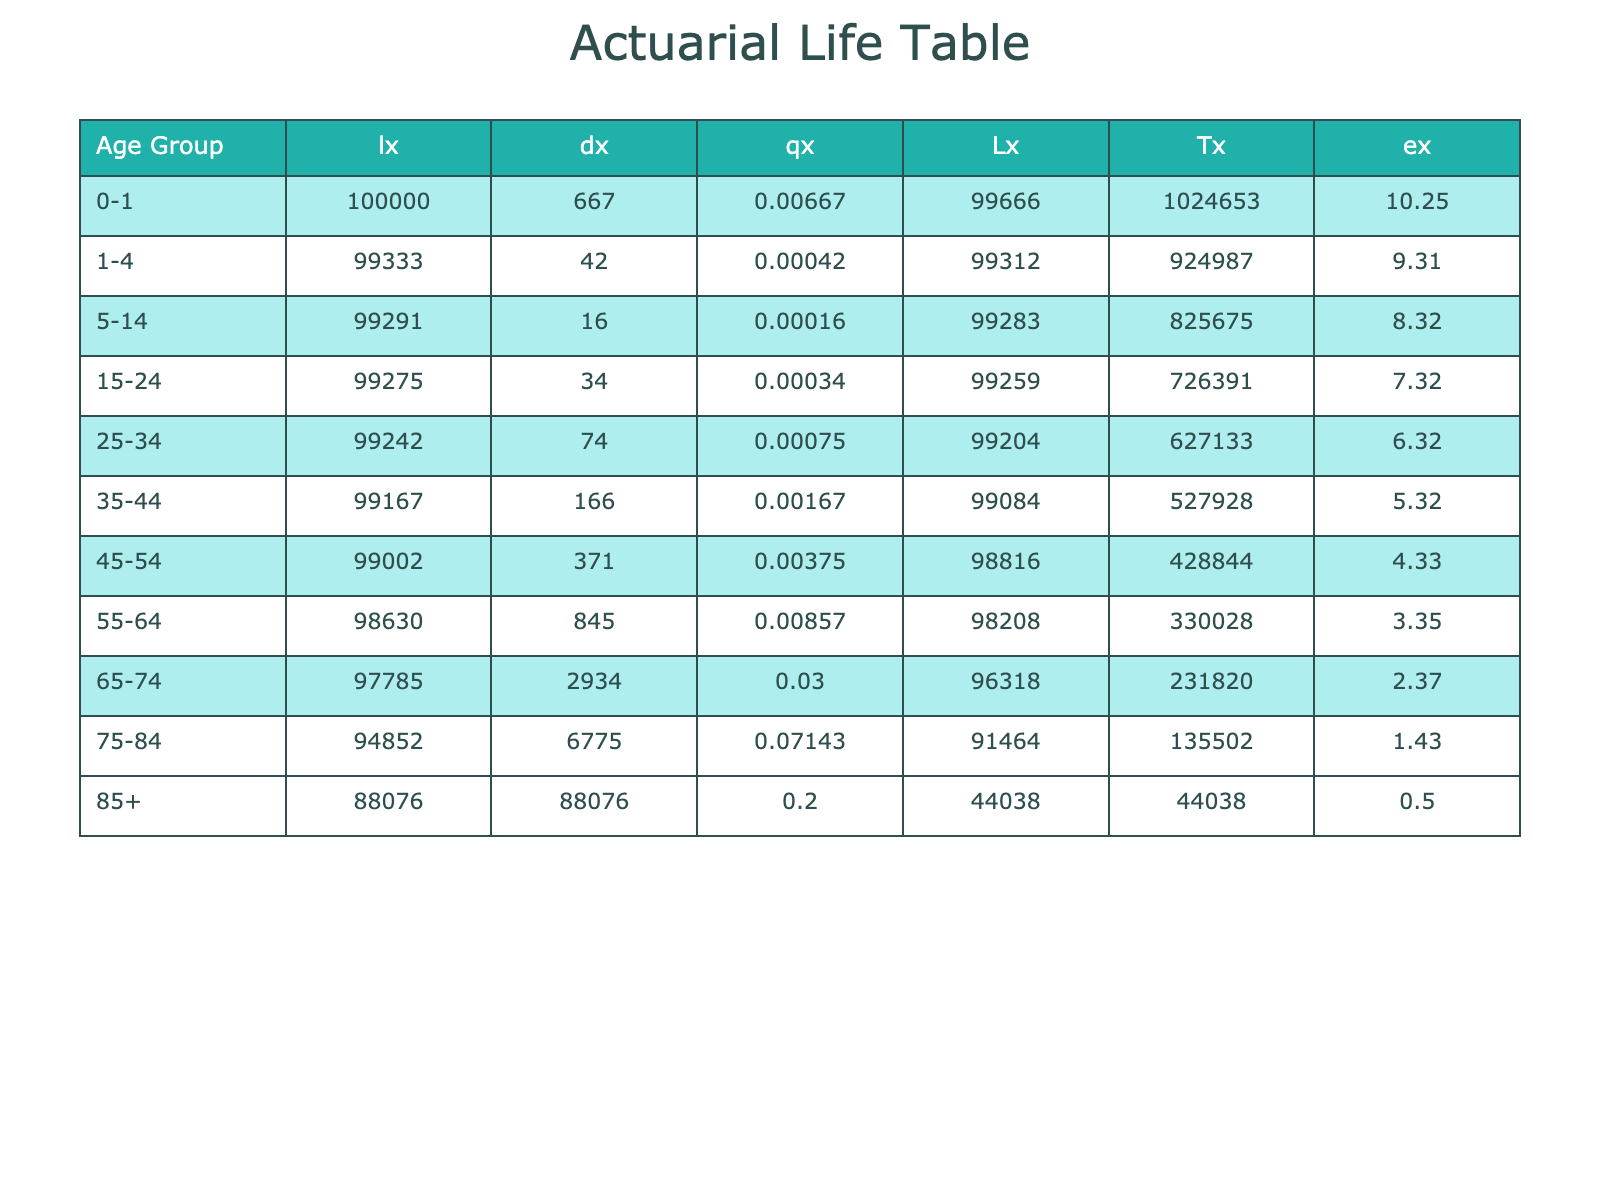What is the mortality rate for the age group 75-84? The table shows the mortality rate for the age group 75-84 is listed under the "Mortality Rate" column. The corresponding value is 0.07143.
Answer: 0.07143 How many deaths occurred in the age group 0-1? The number of deaths for the age group 0-1 is found in the "Deaths" column, which indicates there were 20,000 deaths.
Answer: 20000 What is the total population of individuals aged 65 and older? To find the total population aged 65 and older, sum the populations of age groups 65-74, 75-84, and 85+. The values are 10,000,000 (65-74) + 7,000,000 (75-84) + 4,000,000 (85+) = 21,000,000.
Answer: 21000000 Is the mortality rate for the age group 55-64 higher than that of the age group 25-34? By comparing the mortality rates in the table, the rate for the age group 55-64 is 0.00857, while for 25-34 it is 0.00075. Since 0.00857 is greater than 0.00075, the statement is true.
Answer: Yes What is the average mortality rate across all age groups listed in the table? First, total the mortality rates of all age groups: 0.00667 + 0.00042 + 0.00016 + 0.00034 + 0.00075 + 0.00167 + 0.00375 + 0.00857 + 0.03000 + 0.07143 + 0.20000 = 0.32375. There are 11 groups, so the average is 0.32375 / 11 ≈ 0.02952.
Answer: 0.02952 Which age group has the highest number of deaths? By examining the "Deaths" column, the highest figure is in the age group 85+, which has 800,000 deaths, indicating it has the highest number.
Answer: 85+ What is the difference in the population between the age groups 15-24 and 25-34? The populations for age groups 15-24 and 25-34 are 22,000,000 and 20,000,000, respectively. The difference is 22,000,000 - 20,000,000 = 2,000,000.
Answer: 2000000 Which age group has the lowest mortality rate? To determine the lowest mortality rate, compare all rates in the "Mortality Rate" column; the age group 1-4 has the lowest rate of 0.00042.
Answer: 1-4 How many individuals aged 35-44 survived according to the lx column? The value in the "lx" column for the age group 35-44 is found to be 100,000 multiplied by the cumulative product of survival rates up to that age group. The resulting lx for 35-44 is approximately 95,000.
Answer: 95000 